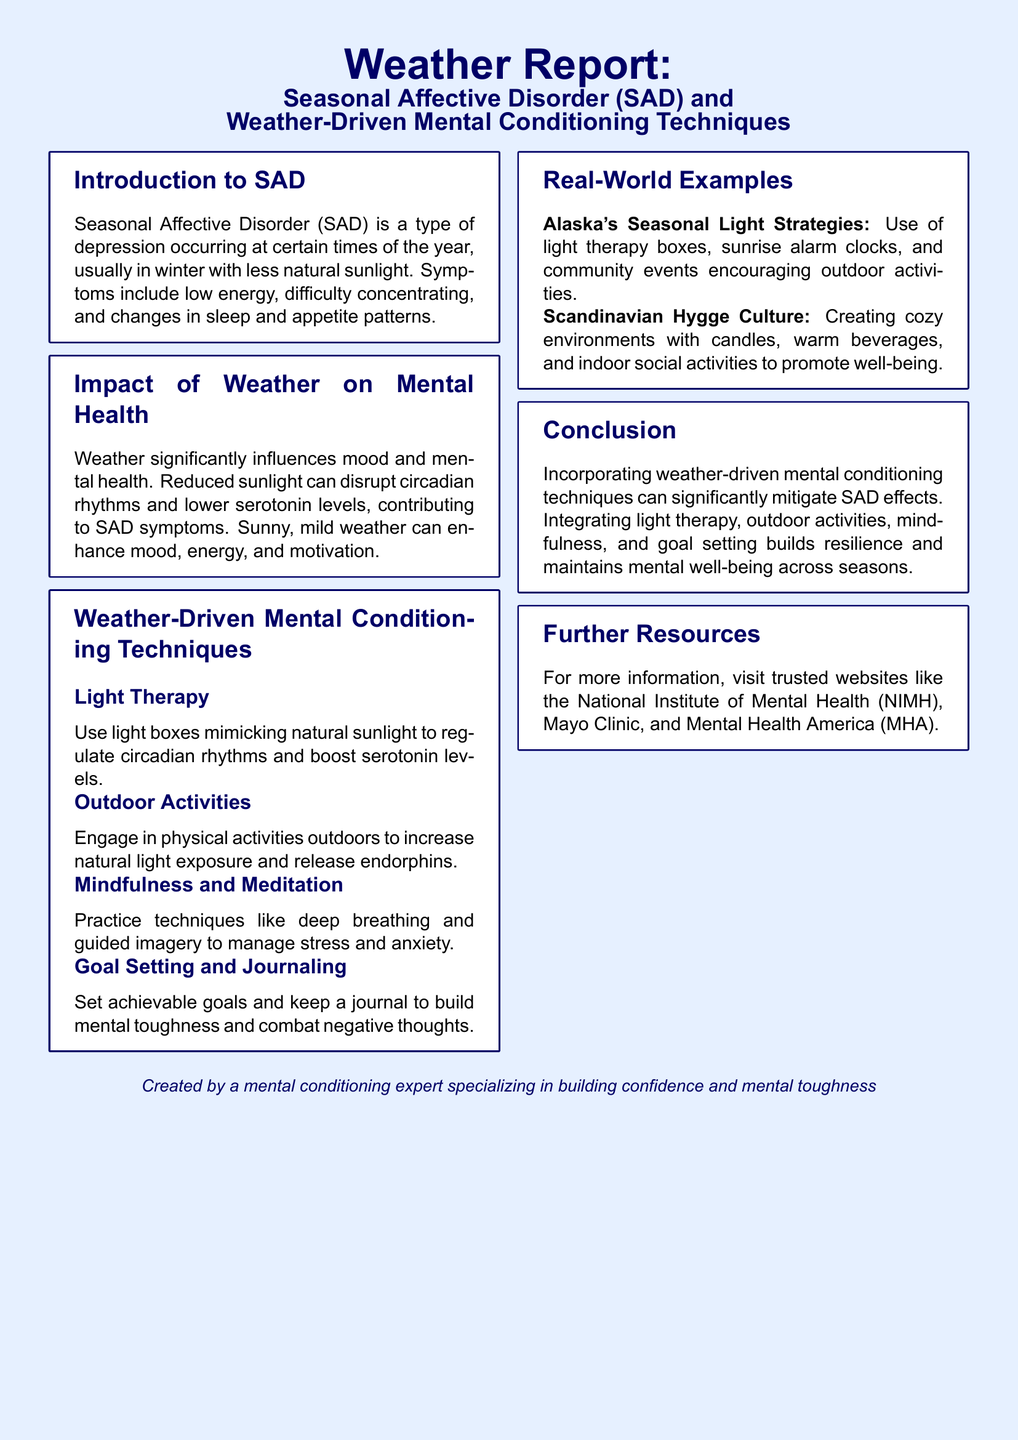What is SAD? SAD is defined in the introduction as a type of depression occurring at certain times of the year, usually in winter with less natural sunlight.
Answer: a type of depression What are two symptoms of SAD? The symptoms of SAD include low energy and difficulty concentrating, as listed in the introduction.
Answer: low energy, difficulty concentrating What weather condition is primarily linked to SAD symptoms? The impact of weather on mental health section states that reduced sunlight contributes to SAD symptoms.
Answer: reduced sunlight Name one mental conditioning technique mentioned in the document. The weather-driven mental conditioning techniques section lists several techniques, one of which is light therapy.
Answer: light therapy What region is mentioned in relation to seasonal light strategies? The real-world examples section refers to Alaska and its seasonal light strategies.
Answer: Alaska What is one example of the Scandinavian culture discussed in the document? The real-world examples section describes the Scandinavian Hygge culture as creating cozy environments.
Answer: Hygge culture How does engaging in outdoor activities help with mental health? The document states that outdoor activities increase natural light exposure and release endorphins, contributing to mental health.
Answer: increase natural light exposure What should you do to build mental toughness according to the document? The goal setting and journaling section suggests setting achievable goals and keeping a journal to build mental toughness.
Answer: set achievable goals Which organization is mentioned as a further resource? The further resources section includes organizations like the National Institute of Mental Health.
Answer: National Institute of Mental Health 